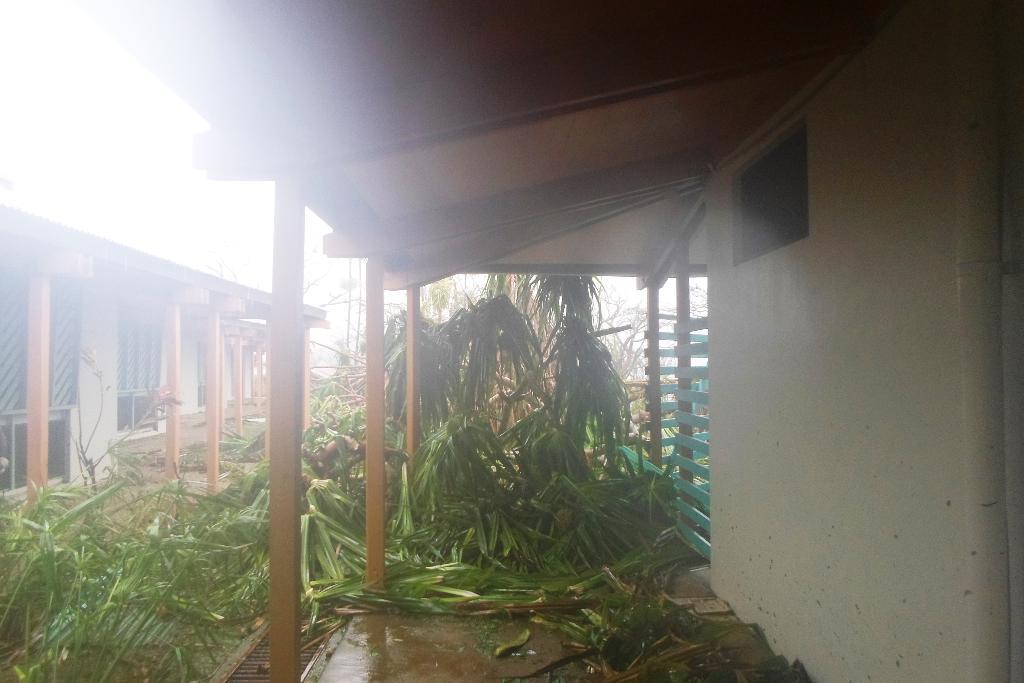What type of vegetation can be seen in the image? There are trees in the image. What type of structures are present in the image? There are houses in the image. What type of alley can be seen in the image? There is no alley present in the image. What type of fowl is visible in the image? There is no fowl present in the image. 